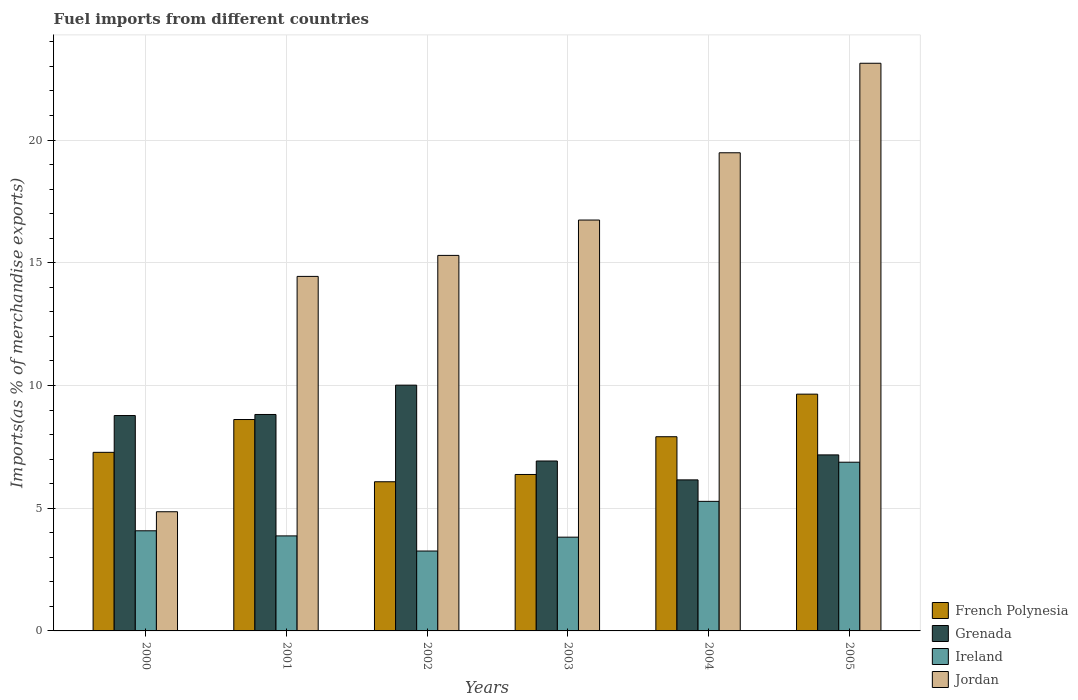How many different coloured bars are there?
Keep it short and to the point. 4. Are the number of bars per tick equal to the number of legend labels?
Give a very brief answer. Yes. How many bars are there on the 3rd tick from the left?
Keep it short and to the point. 4. In how many cases, is the number of bars for a given year not equal to the number of legend labels?
Give a very brief answer. 0. What is the percentage of imports to different countries in Grenada in 2005?
Offer a terse response. 7.17. Across all years, what is the maximum percentage of imports to different countries in French Polynesia?
Your answer should be very brief. 9.65. Across all years, what is the minimum percentage of imports to different countries in Grenada?
Make the answer very short. 6.15. In which year was the percentage of imports to different countries in Ireland maximum?
Give a very brief answer. 2005. What is the total percentage of imports to different countries in Jordan in the graph?
Your answer should be very brief. 93.95. What is the difference between the percentage of imports to different countries in Jordan in 2000 and that in 2002?
Ensure brevity in your answer.  -10.44. What is the difference between the percentage of imports to different countries in Ireland in 2002 and the percentage of imports to different countries in French Polynesia in 2004?
Ensure brevity in your answer.  -4.66. What is the average percentage of imports to different countries in Jordan per year?
Keep it short and to the point. 15.66. In the year 2000, what is the difference between the percentage of imports to different countries in French Polynesia and percentage of imports to different countries in Jordan?
Provide a short and direct response. 2.42. What is the ratio of the percentage of imports to different countries in Jordan in 2001 to that in 2002?
Your response must be concise. 0.94. Is the percentage of imports to different countries in French Polynesia in 2001 less than that in 2004?
Give a very brief answer. No. What is the difference between the highest and the second highest percentage of imports to different countries in Ireland?
Ensure brevity in your answer.  1.6. What is the difference between the highest and the lowest percentage of imports to different countries in Jordan?
Offer a terse response. 18.27. In how many years, is the percentage of imports to different countries in Jordan greater than the average percentage of imports to different countries in Jordan taken over all years?
Offer a terse response. 3. Is the sum of the percentage of imports to different countries in Grenada in 2001 and 2002 greater than the maximum percentage of imports to different countries in Jordan across all years?
Make the answer very short. No. Is it the case that in every year, the sum of the percentage of imports to different countries in Grenada and percentage of imports to different countries in Jordan is greater than the sum of percentage of imports to different countries in French Polynesia and percentage of imports to different countries in Ireland?
Your answer should be compact. No. What does the 2nd bar from the left in 2001 represents?
Ensure brevity in your answer.  Grenada. What does the 1st bar from the right in 2002 represents?
Offer a very short reply. Jordan. Is it the case that in every year, the sum of the percentage of imports to different countries in Jordan and percentage of imports to different countries in Ireland is greater than the percentage of imports to different countries in French Polynesia?
Ensure brevity in your answer.  Yes. How many bars are there?
Your answer should be very brief. 24. How many years are there in the graph?
Provide a short and direct response. 6. Does the graph contain any zero values?
Give a very brief answer. No. Does the graph contain grids?
Your answer should be compact. Yes. How many legend labels are there?
Make the answer very short. 4. What is the title of the graph?
Ensure brevity in your answer.  Fuel imports from different countries. Does "Argentina" appear as one of the legend labels in the graph?
Keep it short and to the point. No. What is the label or title of the X-axis?
Make the answer very short. Years. What is the label or title of the Y-axis?
Provide a short and direct response. Imports(as % of merchandise exports). What is the Imports(as % of merchandise exports) of French Polynesia in 2000?
Offer a terse response. 7.28. What is the Imports(as % of merchandise exports) of Grenada in 2000?
Offer a terse response. 8.78. What is the Imports(as % of merchandise exports) of Ireland in 2000?
Offer a very short reply. 4.08. What is the Imports(as % of merchandise exports) of Jordan in 2000?
Your answer should be very brief. 4.86. What is the Imports(as % of merchandise exports) of French Polynesia in 2001?
Ensure brevity in your answer.  8.61. What is the Imports(as % of merchandise exports) in Grenada in 2001?
Give a very brief answer. 8.82. What is the Imports(as % of merchandise exports) in Ireland in 2001?
Offer a very short reply. 3.87. What is the Imports(as % of merchandise exports) of Jordan in 2001?
Offer a terse response. 14.44. What is the Imports(as % of merchandise exports) of French Polynesia in 2002?
Make the answer very short. 6.08. What is the Imports(as % of merchandise exports) in Grenada in 2002?
Your response must be concise. 10.01. What is the Imports(as % of merchandise exports) in Ireland in 2002?
Provide a succinct answer. 3.26. What is the Imports(as % of merchandise exports) of Jordan in 2002?
Your answer should be compact. 15.3. What is the Imports(as % of merchandise exports) in French Polynesia in 2003?
Your response must be concise. 6.37. What is the Imports(as % of merchandise exports) in Grenada in 2003?
Your answer should be compact. 6.92. What is the Imports(as % of merchandise exports) in Ireland in 2003?
Your answer should be compact. 3.82. What is the Imports(as % of merchandise exports) in Jordan in 2003?
Your response must be concise. 16.74. What is the Imports(as % of merchandise exports) of French Polynesia in 2004?
Ensure brevity in your answer.  7.91. What is the Imports(as % of merchandise exports) in Grenada in 2004?
Make the answer very short. 6.15. What is the Imports(as % of merchandise exports) in Ireland in 2004?
Your response must be concise. 5.28. What is the Imports(as % of merchandise exports) of Jordan in 2004?
Your response must be concise. 19.48. What is the Imports(as % of merchandise exports) of French Polynesia in 2005?
Keep it short and to the point. 9.65. What is the Imports(as % of merchandise exports) of Grenada in 2005?
Keep it short and to the point. 7.17. What is the Imports(as % of merchandise exports) of Ireland in 2005?
Make the answer very short. 6.87. What is the Imports(as % of merchandise exports) of Jordan in 2005?
Provide a succinct answer. 23.13. Across all years, what is the maximum Imports(as % of merchandise exports) of French Polynesia?
Your answer should be compact. 9.65. Across all years, what is the maximum Imports(as % of merchandise exports) of Grenada?
Provide a short and direct response. 10.01. Across all years, what is the maximum Imports(as % of merchandise exports) in Ireland?
Make the answer very short. 6.87. Across all years, what is the maximum Imports(as % of merchandise exports) of Jordan?
Offer a very short reply. 23.13. Across all years, what is the minimum Imports(as % of merchandise exports) in French Polynesia?
Offer a very short reply. 6.08. Across all years, what is the minimum Imports(as % of merchandise exports) of Grenada?
Your response must be concise. 6.15. Across all years, what is the minimum Imports(as % of merchandise exports) of Ireland?
Offer a very short reply. 3.26. Across all years, what is the minimum Imports(as % of merchandise exports) of Jordan?
Your answer should be compact. 4.86. What is the total Imports(as % of merchandise exports) in French Polynesia in the graph?
Keep it short and to the point. 45.9. What is the total Imports(as % of merchandise exports) of Grenada in the graph?
Offer a terse response. 47.86. What is the total Imports(as % of merchandise exports) in Ireland in the graph?
Give a very brief answer. 27.18. What is the total Imports(as % of merchandise exports) in Jordan in the graph?
Your response must be concise. 93.95. What is the difference between the Imports(as % of merchandise exports) of French Polynesia in 2000 and that in 2001?
Give a very brief answer. -1.34. What is the difference between the Imports(as % of merchandise exports) in Grenada in 2000 and that in 2001?
Your answer should be compact. -0.04. What is the difference between the Imports(as % of merchandise exports) of Ireland in 2000 and that in 2001?
Give a very brief answer. 0.21. What is the difference between the Imports(as % of merchandise exports) in Jordan in 2000 and that in 2001?
Your answer should be very brief. -9.59. What is the difference between the Imports(as % of merchandise exports) of French Polynesia in 2000 and that in 2002?
Ensure brevity in your answer.  1.2. What is the difference between the Imports(as % of merchandise exports) in Grenada in 2000 and that in 2002?
Give a very brief answer. -1.24. What is the difference between the Imports(as % of merchandise exports) in Ireland in 2000 and that in 2002?
Offer a very short reply. 0.82. What is the difference between the Imports(as % of merchandise exports) in Jordan in 2000 and that in 2002?
Your answer should be very brief. -10.44. What is the difference between the Imports(as % of merchandise exports) in French Polynesia in 2000 and that in 2003?
Give a very brief answer. 0.9. What is the difference between the Imports(as % of merchandise exports) in Grenada in 2000 and that in 2003?
Your answer should be very brief. 1.85. What is the difference between the Imports(as % of merchandise exports) in Ireland in 2000 and that in 2003?
Your response must be concise. 0.26. What is the difference between the Imports(as % of merchandise exports) in Jordan in 2000 and that in 2003?
Make the answer very short. -11.88. What is the difference between the Imports(as % of merchandise exports) of French Polynesia in 2000 and that in 2004?
Your response must be concise. -0.64. What is the difference between the Imports(as % of merchandise exports) in Grenada in 2000 and that in 2004?
Offer a terse response. 2.62. What is the difference between the Imports(as % of merchandise exports) in Ireland in 2000 and that in 2004?
Your response must be concise. -1.2. What is the difference between the Imports(as % of merchandise exports) of Jordan in 2000 and that in 2004?
Offer a very short reply. -14.63. What is the difference between the Imports(as % of merchandise exports) in French Polynesia in 2000 and that in 2005?
Your answer should be very brief. -2.37. What is the difference between the Imports(as % of merchandise exports) of Grenada in 2000 and that in 2005?
Make the answer very short. 1.6. What is the difference between the Imports(as % of merchandise exports) of Ireland in 2000 and that in 2005?
Ensure brevity in your answer.  -2.79. What is the difference between the Imports(as % of merchandise exports) of Jordan in 2000 and that in 2005?
Your answer should be very brief. -18.27. What is the difference between the Imports(as % of merchandise exports) in French Polynesia in 2001 and that in 2002?
Provide a short and direct response. 2.54. What is the difference between the Imports(as % of merchandise exports) of Grenada in 2001 and that in 2002?
Your answer should be compact. -1.19. What is the difference between the Imports(as % of merchandise exports) in Ireland in 2001 and that in 2002?
Provide a succinct answer. 0.62. What is the difference between the Imports(as % of merchandise exports) in Jordan in 2001 and that in 2002?
Ensure brevity in your answer.  -0.86. What is the difference between the Imports(as % of merchandise exports) of French Polynesia in 2001 and that in 2003?
Provide a succinct answer. 2.24. What is the difference between the Imports(as % of merchandise exports) of Grenada in 2001 and that in 2003?
Keep it short and to the point. 1.9. What is the difference between the Imports(as % of merchandise exports) in Ireland in 2001 and that in 2003?
Ensure brevity in your answer.  0.05. What is the difference between the Imports(as % of merchandise exports) of Jordan in 2001 and that in 2003?
Your answer should be very brief. -2.3. What is the difference between the Imports(as % of merchandise exports) in French Polynesia in 2001 and that in 2004?
Your answer should be very brief. 0.7. What is the difference between the Imports(as % of merchandise exports) of Grenada in 2001 and that in 2004?
Give a very brief answer. 2.66. What is the difference between the Imports(as % of merchandise exports) of Ireland in 2001 and that in 2004?
Offer a terse response. -1.41. What is the difference between the Imports(as % of merchandise exports) in Jordan in 2001 and that in 2004?
Offer a terse response. -5.04. What is the difference between the Imports(as % of merchandise exports) of French Polynesia in 2001 and that in 2005?
Keep it short and to the point. -1.03. What is the difference between the Imports(as % of merchandise exports) of Grenada in 2001 and that in 2005?
Make the answer very short. 1.65. What is the difference between the Imports(as % of merchandise exports) in Ireland in 2001 and that in 2005?
Ensure brevity in your answer.  -3. What is the difference between the Imports(as % of merchandise exports) in Jordan in 2001 and that in 2005?
Offer a terse response. -8.68. What is the difference between the Imports(as % of merchandise exports) of French Polynesia in 2002 and that in 2003?
Give a very brief answer. -0.3. What is the difference between the Imports(as % of merchandise exports) of Grenada in 2002 and that in 2003?
Offer a terse response. 3.09. What is the difference between the Imports(as % of merchandise exports) in Ireland in 2002 and that in 2003?
Ensure brevity in your answer.  -0.56. What is the difference between the Imports(as % of merchandise exports) in Jordan in 2002 and that in 2003?
Your response must be concise. -1.44. What is the difference between the Imports(as % of merchandise exports) of French Polynesia in 2002 and that in 2004?
Make the answer very short. -1.83. What is the difference between the Imports(as % of merchandise exports) in Grenada in 2002 and that in 2004?
Offer a terse response. 3.86. What is the difference between the Imports(as % of merchandise exports) in Ireland in 2002 and that in 2004?
Your response must be concise. -2.02. What is the difference between the Imports(as % of merchandise exports) of Jordan in 2002 and that in 2004?
Your response must be concise. -4.18. What is the difference between the Imports(as % of merchandise exports) in French Polynesia in 2002 and that in 2005?
Offer a terse response. -3.57. What is the difference between the Imports(as % of merchandise exports) in Grenada in 2002 and that in 2005?
Your answer should be compact. 2.84. What is the difference between the Imports(as % of merchandise exports) of Ireland in 2002 and that in 2005?
Ensure brevity in your answer.  -3.62. What is the difference between the Imports(as % of merchandise exports) in Jordan in 2002 and that in 2005?
Make the answer very short. -7.83. What is the difference between the Imports(as % of merchandise exports) in French Polynesia in 2003 and that in 2004?
Keep it short and to the point. -1.54. What is the difference between the Imports(as % of merchandise exports) of Grenada in 2003 and that in 2004?
Ensure brevity in your answer.  0.77. What is the difference between the Imports(as % of merchandise exports) of Ireland in 2003 and that in 2004?
Provide a succinct answer. -1.46. What is the difference between the Imports(as % of merchandise exports) in Jordan in 2003 and that in 2004?
Your response must be concise. -2.74. What is the difference between the Imports(as % of merchandise exports) of French Polynesia in 2003 and that in 2005?
Provide a short and direct response. -3.27. What is the difference between the Imports(as % of merchandise exports) in Grenada in 2003 and that in 2005?
Make the answer very short. -0.25. What is the difference between the Imports(as % of merchandise exports) in Ireland in 2003 and that in 2005?
Make the answer very short. -3.05. What is the difference between the Imports(as % of merchandise exports) in Jordan in 2003 and that in 2005?
Your answer should be compact. -6.39. What is the difference between the Imports(as % of merchandise exports) in French Polynesia in 2004 and that in 2005?
Offer a terse response. -1.73. What is the difference between the Imports(as % of merchandise exports) of Grenada in 2004 and that in 2005?
Keep it short and to the point. -1.02. What is the difference between the Imports(as % of merchandise exports) in Ireland in 2004 and that in 2005?
Offer a very short reply. -1.59. What is the difference between the Imports(as % of merchandise exports) of Jordan in 2004 and that in 2005?
Keep it short and to the point. -3.65. What is the difference between the Imports(as % of merchandise exports) of French Polynesia in 2000 and the Imports(as % of merchandise exports) of Grenada in 2001?
Your response must be concise. -1.54. What is the difference between the Imports(as % of merchandise exports) in French Polynesia in 2000 and the Imports(as % of merchandise exports) in Ireland in 2001?
Provide a succinct answer. 3.4. What is the difference between the Imports(as % of merchandise exports) in French Polynesia in 2000 and the Imports(as % of merchandise exports) in Jordan in 2001?
Ensure brevity in your answer.  -7.17. What is the difference between the Imports(as % of merchandise exports) of Grenada in 2000 and the Imports(as % of merchandise exports) of Ireland in 2001?
Ensure brevity in your answer.  4.9. What is the difference between the Imports(as % of merchandise exports) in Grenada in 2000 and the Imports(as % of merchandise exports) in Jordan in 2001?
Provide a short and direct response. -5.67. What is the difference between the Imports(as % of merchandise exports) of Ireland in 2000 and the Imports(as % of merchandise exports) of Jordan in 2001?
Provide a short and direct response. -10.36. What is the difference between the Imports(as % of merchandise exports) of French Polynesia in 2000 and the Imports(as % of merchandise exports) of Grenada in 2002?
Your response must be concise. -2.74. What is the difference between the Imports(as % of merchandise exports) in French Polynesia in 2000 and the Imports(as % of merchandise exports) in Ireland in 2002?
Your answer should be compact. 4.02. What is the difference between the Imports(as % of merchandise exports) in French Polynesia in 2000 and the Imports(as % of merchandise exports) in Jordan in 2002?
Keep it short and to the point. -8.02. What is the difference between the Imports(as % of merchandise exports) of Grenada in 2000 and the Imports(as % of merchandise exports) of Ireland in 2002?
Make the answer very short. 5.52. What is the difference between the Imports(as % of merchandise exports) of Grenada in 2000 and the Imports(as % of merchandise exports) of Jordan in 2002?
Keep it short and to the point. -6.52. What is the difference between the Imports(as % of merchandise exports) of Ireland in 2000 and the Imports(as % of merchandise exports) of Jordan in 2002?
Keep it short and to the point. -11.22. What is the difference between the Imports(as % of merchandise exports) of French Polynesia in 2000 and the Imports(as % of merchandise exports) of Grenada in 2003?
Offer a terse response. 0.35. What is the difference between the Imports(as % of merchandise exports) in French Polynesia in 2000 and the Imports(as % of merchandise exports) in Ireland in 2003?
Offer a very short reply. 3.46. What is the difference between the Imports(as % of merchandise exports) in French Polynesia in 2000 and the Imports(as % of merchandise exports) in Jordan in 2003?
Keep it short and to the point. -9.46. What is the difference between the Imports(as % of merchandise exports) of Grenada in 2000 and the Imports(as % of merchandise exports) of Ireland in 2003?
Give a very brief answer. 4.96. What is the difference between the Imports(as % of merchandise exports) in Grenada in 2000 and the Imports(as % of merchandise exports) in Jordan in 2003?
Provide a succinct answer. -7.96. What is the difference between the Imports(as % of merchandise exports) of Ireland in 2000 and the Imports(as % of merchandise exports) of Jordan in 2003?
Provide a short and direct response. -12.66. What is the difference between the Imports(as % of merchandise exports) in French Polynesia in 2000 and the Imports(as % of merchandise exports) in Grenada in 2004?
Make the answer very short. 1.12. What is the difference between the Imports(as % of merchandise exports) in French Polynesia in 2000 and the Imports(as % of merchandise exports) in Ireland in 2004?
Offer a terse response. 2. What is the difference between the Imports(as % of merchandise exports) in French Polynesia in 2000 and the Imports(as % of merchandise exports) in Jordan in 2004?
Provide a short and direct response. -12.21. What is the difference between the Imports(as % of merchandise exports) of Grenada in 2000 and the Imports(as % of merchandise exports) of Ireland in 2004?
Provide a short and direct response. 3.5. What is the difference between the Imports(as % of merchandise exports) of Grenada in 2000 and the Imports(as % of merchandise exports) of Jordan in 2004?
Provide a short and direct response. -10.71. What is the difference between the Imports(as % of merchandise exports) in Ireland in 2000 and the Imports(as % of merchandise exports) in Jordan in 2004?
Provide a short and direct response. -15.4. What is the difference between the Imports(as % of merchandise exports) in French Polynesia in 2000 and the Imports(as % of merchandise exports) in Grenada in 2005?
Ensure brevity in your answer.  0.1. What is the difference between the Imports(as % of merchandise exports) in French Polynesia in 2000 and the Imports(as % of merchandise exports) in Ireland in 2005?
Provide a succinct answer. 0.4. What is the difference between the Imports(as % of merchandise exports) of French Polynesia in 2000 and the Imports(as % of merchandise exports) of Jordan in 2005?
Make the answer very short. -15.85. What is the difference between the Imports(as % of merchandise exports) in Grenada in 2000 and the Imports(as % of merchandise exports) in Ireland in 2005?
Make the answer very short. 1.9. What is the difference between the Imports(as % of merchandise exports) in Grenada in 2000 and the Imports(as % of merchandise exports) in Jordan in 2005?
Offer a very short reply. -14.35. What is the difference between the Imports(as % of merchandise exports) of Ireland in 2000 and the Imports(as % of merchandise exports) of Jordan in 2005?
Provide a succinct answer. -19.05. What is the difference between the Imports(as % of merchandise exports) in French Polynesia in 2001 and the Imports(as % of merchandise exports) in Grenada in 2002?
Offer a terse response. -1.4. What is the difference between the Imports(as % of merchandise exports) of French Polynesia in 2001 and the Imports(as % of merchandise exports) of Ireland in 2002?
Provide a short and direct response. 5.36. What is the difference between the Imports(as % of merchandise exports) of French Polynesia in 2001 and the Imports(as % of merchandise exports) of Jordan in 2002?
Your answer should be very brief. -6.69. What is the difference between the Imports(as % of merchandise exports) of Grenada in 2001 and the Imports(as % of merchandise exports) of Ireland in 2002?
Your response must be concise. 5.56. What is the difference between the Imports(as % of merchandise exports) in Grenada in 2001 and the Imports(as % of merchandise exports) in Jordan in 2002?
Give a very brief answer. -6.48. What is the difference between the Imports(as % of merchandise exports) in Ireland in 2001 and the Imports(as % of merchandise exports) in Jordan in 2002?
Offer a very short reply. -11.43. What is the difference between the Imports(as % of merchandise exports) in French Polynesia in 2001 and the Imports(as % of merchandise exports) in Grenada in 2003?
Your answer should be very brief. 1.69. What is the difference between the Imports(as % of merchandise exports) of French Polynesia in 2001 and the Imports(as % of merchandise exports) of Ireland in 2003?
Provide a succinct answer. 4.79. What is the difference between the Imports(as % of merchandise exports) of French Polynesia in 2001 and the Imports(as % of merchandise exports) of Jordan in 2003?
Keep it short and to the point. -8.13. What is the difference between the Imports(as % of merchandise exports) in Grenada in 2001 and the Imports(as % of merchandise exports) in Ireland in 2003?
Offer a terse response. 5. What is the difference between the Imports(as % of merchandise exports) of Grenada in 2001 and the Imports(as % of merchandise exports) of Jordan in 2003?
Offer a terse response. -7.92. What is the difference between the Imports(as % of merchandise exports) of Ireland in 2001 and the Imports(as % of merchandise exports) of Jordan in 2003?
Offer a very short reply. -12.87. What is the difference between the Imports(as % of merchandise exports) of French Polynesia in 2001 and the Imports(as % of merchandise exports) of Grenada in 2004?
Offer a terse response. 2.46. What is the difference between the Imports(as % of merchandise exports) in French Polynesia in 2001 and the Imports(as % of merchandise exports) in Ireland in 2004?
Ensure brevity in your answer.  3.33. What is the difference between the Imports(as % of merchandise exports) in French Polynesia in 2001 and the Imports(as % of merchandise exports) in Jordan in 2004?
Your response must be concise. -10.87. What is the difference between the Imports(as % of merchandise exports) in Grenada in 2001 and the Imports(as % of merchandise exports) in Ireland in 2004?
Offer a very short reply. 3.54. What is the difference between the Imports(as % of merchandise exports) in Grenada in 2001 and the Imports(as % of merchandise exports) in Jordan in 2004?
Make the answer very short. -10.66. What is the difference between the Imports(as % of merchandise exports) in Ireland in 2001 and the Imports(as % of merchandise exports) in Jordan in 2004?
Offer a terse response. -15.61. What is the difference between the Imports(as % of merchandise exports) of French Polynesia in 2001 and the Imports(as % of merchandise exports) of Grenada in 2005?
Keep it short and to the point. 1.44. What is the difference between the Imports(as % of merchandise exports) of French Polynesia in 2001 and the Imports(as % of merchandise exports) of Ireland in 2005?
Your response must be concise. 1.74. What is the difference between the Imports(as % of merchandise exports) of French Polynesia in 2001 and the Imports(as % of merchandise exports) of Jordan in 2005?
Provide a succinct answer. -14.52. What is the difference between the Imports(as % of merchandise exports) of Grenada in 2001 and the Imports(as % of merchandise exports) of Ireland in 2005?
Offer a very short reply. 1.94. What is the difference between the Imports(as % of merchandise exports) of Grenada in 2001 and the Imports(as % of merchandise exports) of Jordan in 2005?
Your response must be concise. -14.31. What is the difference between the Imports(as % of merchandise exports) of Ireland in 2001 and the Imports(as % of merchandise exports) of Jordan in 2005?
Offer a very short reply. -19.26. What is the difference between the Imports(as % of merchandise exports) in French Polynesia in 2002 and the Imports(as % of merchandise exports) in Grenada in 2003?
Give a very brief answer. -0.85. What is the difference between the Imports(as % of merchandise exports) of French Polynesia in 2002 and the Imports(as % of merchandise exports) of Ireland in 2003?
Provide a succinct answer. 2.26. What is the difference between the Imports(as % of merchandise exports) of French Polynesia in 2002 and the Imports(as % of merchandise exports) of Jordan in 2003?
Offer a very short reply. -10.66. What is the difference between the Imports(as % of merchandise exports) in Grenada in 2002 and the Imports(as % of merchandise exports) in Ireland in 2003?
Give a very brief answer. 6.19. What is the difference between the Imports(as % of merchandise exports) in Grenada in 2002 and the Imports(as % of merchandise exports) in Jordan in 2003?
Give a very brief answer. -6.73. What is the difference between the Imports(as % of merchandise exports) of Ireland in 2002 and the Imports(as % of merchandise exports) of Jordan in 2003?
Your answer should be very brief. -13.48. What is the difference between the Imports(as % of merchandise exports) in French Polynesia in 2002 and the Imports(as % of merchandise exports) in Grenada in 2004?
Keep it short and to the point. -0.08. What is the difference between the Imports(as % of merchandise exports) in French Polynesia in 2002 and the Imports(as % of merchandise exports) in Ireland in 2004?
Your answer should be compact. 0.8. What is the difference between the Imports(as % of merchandise exports) of French Polynesia in 2002 and the Imports(as % of merchandise exports) of Jordan in 2004?
Provide a succinct answer. -13.4. What is the difference between the Imports(as % of merchandise exports) of Grenada in 2002 and the Imports(as % of merchandise exports) of Ireland in 2004?
Provide a short and direct response. 4.73. What is the difference between the Imports(as % of merchandise exports) of Grenada in 2002 and the Imports(as % of merchandise exports) of Jordan in 2004?
Your answer should be compact. -9.47. What is the difference between the Imports(as % of merchandise exports) of Ireland in 2002 and the Imports(as % of merchandise exports) of Jordan in 2004?
Your answer should be very brief. -16.23. What is the difference between the Imports(as % of merchandise exports) in French Polynesia in 2002 and the Imports(as % of merchandise exports) in Grenada in 2005?
Make the answer very short. -1.09. What is the difference between the Imports(as % of merchandise exports) of French Polynesia in 2002 and the Imports(as % of merchandise exports) of Ireland in 2005?
Your response must be concise. -0.8. What is the difference between the Imports(as % of merchandise exports) of French Polynesia in 2002 and the Imports(as % of merchandise exports) of Jordan in 2005?
Your response must be concise. -17.05. What is the difference between the Imports(as % of merchandise exports) in Grenada in 2002 and the Imports(as % of merchandise exports) in Ireland in 2005?
Offer a terse response. 3.14. What is the difference between the Imports(as % of merchandise exports) in Grenada in 2002 and the Imports(as % of merchandise exports) in Jordan in 2005?
Give a very brief answer. -13.11. What is the difference between the Imports(as % of merchandise exports) of Ireland in 2002 and the Imports(as % of merchandise exports) of Jordan in 2005?
Offer a terse response. -19.87. What is the difference between the Imports(as % of merchandise exports) in French Polynesia in 2003 and the Imports(as % of merchandise exports) in Grenada in 2004?
Your answer should be very brief. 0.22. What is the difference between the Imports(as % of merchandise exports) in French Polynesia in 2003 and the Imports(as % of merchandise exports) in Ireland in 2004?
Your answer should be very brief. 1.09. What is the difference between the Imports(as % of merchandise exports) of French Polynesia in 2003 and the Imports(as % of merchandise exports) of Jordan in 2004?
Provide a short and direct response. -13.11. What is the difference between the Imports(as % of merchandise exports) of Grenada in 2003 and the Imports(as % of merchandise exports) of Ireland in 2004?
Ensure brevity in your answer.  1.64. What is the difference between the Imports(as % of merchandise exports) in Grenada in 2003 and the Imports(as % of merchandise exports) in Jordan in 2004?
Ensure brevity in your answer.  -12.56. What is the difference between the Imports(as % of merchandise exports) in Ireland in 2003 and the Imports(as % of merchandise exports) in Jordan in 2004?
Your response must be concise. -15.66. What is the difference between the Imports(as % of merchandise exports) in French Polynesia in 2003 and the Imports(as % of merchandise exports) in Grenada in 2005?
Your response must be concise. -0.8. What is the difference between the Imports(as % of merchandise exports) of French Polynesia in 2003 and the Imports(as % of merchandise exports) of Ireland in 2005?
Offer a very short reply. -0.5. What is the difference between the Imports(as % of merchandise exports) in French Polynesia in 2003 and the Imports(as % of merchandise exports) in Jordan in 2005?
Offer a terse response. -16.75. What is the difference between the Imports(as % of merchandise exports) of Grenada in 2003 and the Imports(as % of merchandise exports) of Ireland in 2005?
Keep it short and to the point. 0.05. What is the difference between the Imports(as % of merchandise exports) of Grenada in 2003 and the Imports(as % of merchandise exports) of Jordan in 2005?
Your answer should be very brief. -16.2. What is the difference between the Imports(as % of merchandise exports) of Ireland in 2003 and the Imports(as % of merchandise exports) of Jordan in 2005?
Offer a terse response. -19.31. What is the difference between the Imports(as % of merchandise exports) in French Polynesia in 2004 and the Imports(as % of merchandise exports) in Grenada in 2005?
Give a very brief answer. 0.74. What is the difference between the Imports(as % of merchandise exports) in French Polynesia in 2004 and the Imports(as % of merchandise exports) in Ireland in 2005?
Make the answer very short. 1.04. What is the difference between the Imports(as % of merchandise exports) in French Polynesia in 2004 and the Imports(as % of merchandise exports) in Jordan in 2005?
Provide a succinct answer. -15.22. What is the difference between the Imports(as % of merchandise exports) of Grenada in 2004 and the Imports(as % of merchandise exports) of Ireland in 2005?
Make the answer very short. -0.72. What is the difference between the Imports(as % of merchandise exports) in Grenada in 2004 and the Imports(as % of merchandise exports) in Jordan in 2005?
Your response must be concise. -16.97. What is the difference between the Imports(as % of merchandise exports) in Ireland in 2004 and the Imports(as % of merchandise exports) in Jordan in 2005?
Make the answer very short. -17.85. What is the average Imports(as % of merchandise exports) in French Polynesia per year?
Give a very brief answer. 7.65. What is the average Imports(as % of merchandise exports) of Grenada per year?
Your answer should be compact. 7.98. What is the average Imports(as % of merchandise exports) in Ireland per year?
Offer a terse response. 4.53. What is the average Imports(as % of merchandise exports) of Jordan per year?
Your response must be concise. 15.66. In the year 2000, what is the difference between the Imports(as % of merchandise exports) in French Polynesia and Imports(as % of merchandise exports) in Grenada?
Offer a terse response. -1.5. In the year 2000, what is the difference between the Imports(as % of merchandise exports) in French Polynesia and Imports(as % of merchandise exports) in Ireland?
Your response must be concise. 3.2. In the year 2000, what is the difference between the Imports(as % of merchandise exports) in French Polynesia and Imports(as % of merchandise exports) in Jordan?
Make the answer very short. 2.42. In the year 2000, what is the difference between the Imports(as % of merchandise exports) of Grenada and Imports(as % of merchandise exports) of Ireland?
Your answer should be very brief. 4.7. In the year 2000, what is the difference between the Imports(as % of merchandise exports) of Grenada and Imports(as % of merchandise exports) of Jordan?
Ensure brevity in your answer.  3.92. In the year 2000, what is the difference between the Imports(as % of merchandise exports) in Ireland and Imports(as % of merchandise exports) in Jordan?
Your answer should be very brief. -0.78. In the year 2001, what is the difference between the Imports(as % of merchandise exports) in French Polynesia and Imports(as % of merchandise exports) in Grenada?
Ensure brevity in your answer.  -0.21. In the year 2001, what is the difference between the Imports(as % of merchandise exports) of French Polynesia and Imports(as % of merchandise exports) of Ireland?
Keep it short and to the point. 4.74. In the year 2001, what is the difference between the Imports(as % of merchandise exports) in French Polynesia and Imports(as % of merchandise exports) in Jordan?
Give a very brief answer. -5.83. In the year 2001, what is the difference between the Imports(as % of merchandise exports) in Grenada and Imports(as % of merchandise exports) in Ireland?
Your response must be concise. 4.95. In the year 2001, what is the difference between the Imports(as % of merchandise exports) of Grenada and Imports(as % of merchandise exports) of Jordan?
Keep it short and to the point. -5.63. In the year 2001, what is the difference between the Imports(as % of merchandise exports) of Ireland and Imports(as % of merchandise exports) of Jordan?
Your answer should be compact. -10.57. In the year 2002, what is the difference between the Imports(as % of merchandise exports) in French Polynesia and Imports(as % of merchandise exports) in Grenada?
Keep it short and to the point. -3.94. In the year 2002, what is the difference between the Imports(as % of merchandise exports) in French Polynesia and Imports(as % of merchandise exports) in Ireland?
Your answer should be very brief. 2.82. In the year 2002, what is the difference between the Imports(as % of merchandise exports) in French Polynesia and Imports(as % of merchandise exports) in Jordan?
Make the answer very short. -9.22. In the year 2002, what is the difference between the Imports(as % of merchandise exports) of Grenada and Imports(as % of merchandise exports) of Ireland?
Your answer should be very brief. 6.76. In the year 2002, what is the difference between the Imports(as % of merchandise exports) in Grenada and Imports(as % of merchandise exports) in Jordan?
Give a very brief answer. -5.29. In the year 2002, what is the difference between the Imports(as % of merchandise exports) in Ireland and Imports(as % of merchandise exports) in Jordan?
Give a very brief answer. -12.04. In the year 2003, what is the difference between the Imports(as % of merchandise exports) in French Polynesia and Imports(as % of merchandise exports) in Grenada?
Ensure brevity in your answer.  -0.55. In the year 2003, what is the difference between the Imports(as % of merchandise exports) in French Polynesia and Imports(as % of merchandise exports) in Ireland?
Give a very brief answer. 2.55. In the year 2003, what is the difference between the Imports(as % of merchandise exports) of French Polynesia and Imports(as % of merchandise exports) of Jordan?
Your response must be concise. -10.37. In the year 2003, what is the difference between the Imports(as % of merchandise exports) of Grenada and Imports(as % of merchandise exports) of Ireland?
Provide a succinct answer. 3.1. In the year 2003, what is the difference between the Imports(as % of merchandise exports) in Grenada and Imports(as % of merchandise exports) in Jordan?
Your response must be concise. -9.82. In the year 2003, what is the difference between the Imports(as % of merchandise exports) of Ireland and Imports(as % of merchandise exports) of Jordan?
Keep it short and to the point. -12.92. In the year 2004, what is the difference between the Imports(as % of merchandise exports) of French Polynesia and Imports(as % of merchandise exports) of Grenada?
Give a very brief answer. 1.76. In the year 2004, what is the difference between the Imports(as % of merchandise exports) of French Polynesia and Imports(as % of merchandise exports) of Ireland?
Your response must be concise. 2.63. In the year 2004, what is the difference between the Imports(as % of merchandise exports) in French Polynesia and Imports(as % of merchandise exports) in Jordan?
Keep it short and to the point. -11.57. In the year 2004, what is the difference between the Imports(as % of merchandise exports) of Grenada and Imports(as % of merchandise exports) of Ireland?
Give a very brief answer. 0.88. In the year 2004, what is the difference between the Imports(as % of merchandise exports) of Grenada and Imports(as % of merchandise exports) of Jordan?
Provide a succinct answer. -13.33. In the year 2004, what is the difference between the Imports(as % of merchandise exports) of Ireland and Imports(as % of merchandise exports) of Jordan?
Keep it short and to the point. -14.2. In the year 2005, what is the difference between the Imports(as % of merchandise exports) of French Polynesia and Imports(as % of merchandise exports) of Grenada?
Your answer should be very brief. 2.48. In the year 2005, what is the difference between the Imports(as % of merchandise exports) of French Polynesia and Imports(as % of merchandise exports) of Ireland?
Make the answer very short. 2.77. In the year 2005, what is the difference between the Imports(as % of merchandise exports) of French Polynesia and Imports(as % of merchandise exports) of Jordan?
Your response must be concise. -13.48. In the year 2005, what is the difference between the Imports(as % of merchandise exports) in Grenada and Imports(as % of merchandise exports) in Ireland?
Your answer should be compact. 0.3. In the year 2005, what is the difference between the Imports(as % of merchandise exports) in Grenada and Imports(as % of merchandise exports) in Jordan?
Your answer should be very brief. -15.96. In the year 2005, what is the difference between the Imports(as % of merchandise exports) of Ireland and Imports(as % of merchandise exports) of Jordan?
Provide a succinct answer. -16.25. What is the ratio of the Imports(as % of merchandise exports) in French Polynesia in 2000 to that in 2001?
Make the answer very short. 0.84. What is the ratio of the Imports(as % of merchandise exports) of Ireland in 2000 to that in 2001?
Offer a terse response. 1.05. What is the ratio of the Imports(as % of merchandise exports) in Jordan in 2000 to that in 2001?
Your response must be concise. 0.34. What is the ratio of the Imports(as % of merchandise exports) in French Polynesia in 2000 to that in 2002?
Provide a succinct answer. 1.2. What is the ratio of the Imports(as % of merchandise exports) of Grenada in 2000 to that in 2002?
Your answer should be very brief. 0.88. What is the ratio of the Imports(as % of merchandise exports) in Ireland in 2000 to that in 2002?
Your answer should be very brief. 1.25. What is the ratio of the Imports(as % of merchandise exports) in Jordan in 2000 to that in 2002?
Give a very brief answer. 0.32. What is the ratio of the Imports(as % of merchandise exports) in French Polynesia in 2000 to that in 2003?
Provide a succinct answer. 1.14. What is the ratio of the Imports(as % of merchandise exports) of Grenada in 2000 to that in 2003?
Ensure brevity in your answer.  1.27. What is the ratio of the Imports(as % of merchandise exports) of Ireland in 2000 to that in 2003?
Your answer should be very brief. 1.07. What is the ratio of the Imports(as % of merchandise exports) of Jordan in 2000 to that in 2003?
Make the answer very short. 0.29. What is the ratio of the Imports(as % of merchandise exports) of French Polynesia in 2000 to that in 2004?
Make the answer very short. 0.92. What is the ratio of the Imports(as % of merchandise exports) in Grenada in 2000 to that in 2004?
Make the answer very short. 1.43. What is the ratio of the Imports(as % of merchandise exports) of Ireland in 2000 to that in 2004?
Give a very brief answer. 0.77. What is the ratio of the Imports(as % of merchandise exports) of Jordan in 2000 to that in 2004?
Offer a terse response. 0.25. What is the ratio of the Imports(as % of merchandise exports) of French Polynesia in 2000 to that in 2005?
Provide a succinct answer. 0.75. What is the ratio of the Imports(as % of merchandise exports) in Grenada in 2000 to that in 2005?
Offer a terse response. 1.22. What is the ratio of the Imports(as % of merchandise exports) in Ireland in 2000 to that in 2005?
Make the answer very short. 0.59. What is the ratio of the Imports(as % of merchandise exports) in Jordan in 2000 to that in 2005?
Your answer should be very brief. 0.21. What is the ratio of the Imports(as % of merchandise exports) in French Polynesia in 2001 to that in 2002?
Your answer should be compact. 1.42. What is the ratio of the Imports(as % of merchandise exports) of Grenada in 2001 to that in 2002?
Ensure brevity in your answer.  0.88. What is the ratio of the Imports(as % of merchandise exports) of Ireland in 2001 to that in 2002?
Give a very brief answer. 1.19. What is the ratio of the Imports(as % of merchandise exports) in Jordan in 2001 to that in 2002?
Make the answer very short. 0.94. What is the ratio of the Imports(as % of merchandise exports) in French Polynesia in 2001 to that in 2003?
Your answer should be very brief. 1.35. What is the ratio of the Imports(as % of merchandise exports) of Grenada in 2001 to that in 2003?
Provide a succinct answer. 1.27. What is the ratio of the Imports(as % of merchandise exports) of Ireland in 2001 to that in 2003?
Ensure brevity in your answer.  1.01. What is the ratio of the Imports(as % of merchandise exports) in Jordan in 2001 to that in 2003?
Keep it short and to the point. 0.86. What is the ratio of the Imports(as % of merchandise exports) of French Polynesia in 2001 to that in 2004?
Offer a terse response. 1.09. What is the ratio of the Imports(as % of merchandise exports) of Grenada in 2001 to that in 2004?
Give a very brief answer. 1.43. What is the ratio of the Imports(as % of merchandise exports) of Ireland in 2001 to that in 2004?
Keep it short and to the point. 0.73. What is the ratio of the Imports(as % of merchandise exports) of Jordan in 2001 to that in 2004?
Make the answer very short. 0.74. What is the ratio of the Imports(as % of merchandise exports) of French Polynesia in 2001 to that in 2005?
Provide a succinct answer. 0.89. What is the ratio of the Imports(as % of merchandise exports) of Grenada in 2001 to that in 2005?
Make the answer very short. 1.23. What is the ratio of the Imports(as % of merchandise exports) of Ireland in 2001 to that in 2005?
Keep it short and to the point. 0.56. What is the ratio of the Imports(as % of merchandise exports) in Jordan in 2001 to that in 2005?
Your answer should be compact. 0.62. What is the ratio of the Imports(as % of merchandise exports) in French Polynesia in 2002 to that in 2003?
Your answer should be very brief. 0.95. What is the ratio of the Imports(as % of merchandise exports) in Grenada in 2002 to that in 2003?
Ensure brevity in your answer.  1.45. What is the ratio of the Imports(as % of merchandise exports) in Ireland in 2002 to that in 2003?
Provide a succinct answer. 0.85. What is the ratio of the Imports(as % of merchandise exports) of Jordan in 2002 to that in 2003?
Make the answer very short. 0.91. What is the ratio of the Imports(as % of merchandise exports) of French Polynesia in 2002 to that in 2004?
Provide a short and direct response. 0.77. What is the ratio of the Imports(as % of merchandise exports) in Grenada in 2002 to that in 2004?
Provide a succinct answer. 1.63. What is the ratio of the Imports(as % of merchandise exports) of Ireland in 2002 to that in 2004?
Offer a terse response. 0.62. What is the ratio of the Imports(as % of merchandise exports) in Jordan in 2002 to that in 2004?
Offer a terse response. 0.79. What is the ratio of the Imports(as % of merchandise exports) in French Polynesia in 2002 to that in 2005?
Provide a succinct answer. 0.63. What is the ratio of the Imports(as % of merchandise exports) in Grenada in 2002 to that in 2005?
Offer a terse response. 1.4. What is the ratio of the Imports(as % of merchandise exports) in Ireland in 2002 to that in 2005?
Your answer should be very brief. 0.47. What is the ratio of the Imports(as % of merchandise exports) of Jordan in 2002 to that in 2005?
Offer a terse response. 0.66. What is the ratio of the Imports(as % of merchandise exports) in French Polynesia in 2003 to that in 2004?
Provide a succinct answer. 0.81. What is the ratio of the Imports(as % of merchandise exports) in Ireland in 2003 to that in 2004?
Your answer should be very brief. 0.72. What is the ratio of the Imports(as % of merchandise exports) of Jordan in 2003 to that in 2004?
Your answer should be very brief. 0.86. What is the ratio of the Imports(as % of merchandise exports) of French Polynesia in 2003 to that in 2005?
Keep it short and to the point. 0.66. What is the ratio of the Imports(as % of merchandise exports) of Grenada in 2003 to that in 2005?
Keep it short and to the point. 0.97. What is the ratio of the Imports(as % of merchandise exports) in Ireland in 2003 to that in 2005?
Ensure brevity in your answer.  0.56. What is the ratio of the Imports(as % of merchandise exports) of Jordan in 2003 to that in 2005?
Your response must be concise. 0.72. What is the ratio of the Imports(as % of merchandise exports) of French Polynesia in 2004 to that in 2005?
Provide a succinct answer. 0.82. What is the ratio of the Imports(as % of merchandise exports) in Grenada in 2004 to that in 2005?
Keep it short and to the point. 0.86. What is the ratio of the Imports(as % of merchandise exports) in Ireland in 2004 to that in 2005?
Provide a short and direct response. 0.77. What is the ratio of the Imports(as % of merchandise exports) of Jordan in 2004 to that in 2005?
Provide a succinct answer. 0.84. What is the difference between the highest and the second highest Imports(as % of merchandise exports) in French Polynesia?
Provide a short and direct response. 1.03. What is the difference between the highest and the second highest Imports(as % of merchandise exports) in Grenada?
Make the answer very short. 1.19. What is the difference between the highest and the second highest Imports(as % of merchandise exports) of Ireland?
Keep it short and to the point. 1.59. What is the difference between the highest and the second highest Imports(as % of merchandise exports) of Jordan?
Make the answer very short. 3.65. What is the difference between the highest and the lowest Imports(as % of merchandise exports) of French Polynesia?
Ensure brevity in your answer.  3.57. What is the difference between the highest and the lowest Imports(as % of merchandise exports) of Grenada?
Offer a very short reply. 3.86. What is the difference between the highest and the lowest Imports(as % of merchandise exports) of Ireland?
Offer a very short reply. 3.62. What is the difference between the highest and the lowest Imports(as % of merchandise exports) of Jordan?
Provide a short and direct response. 18.27. 